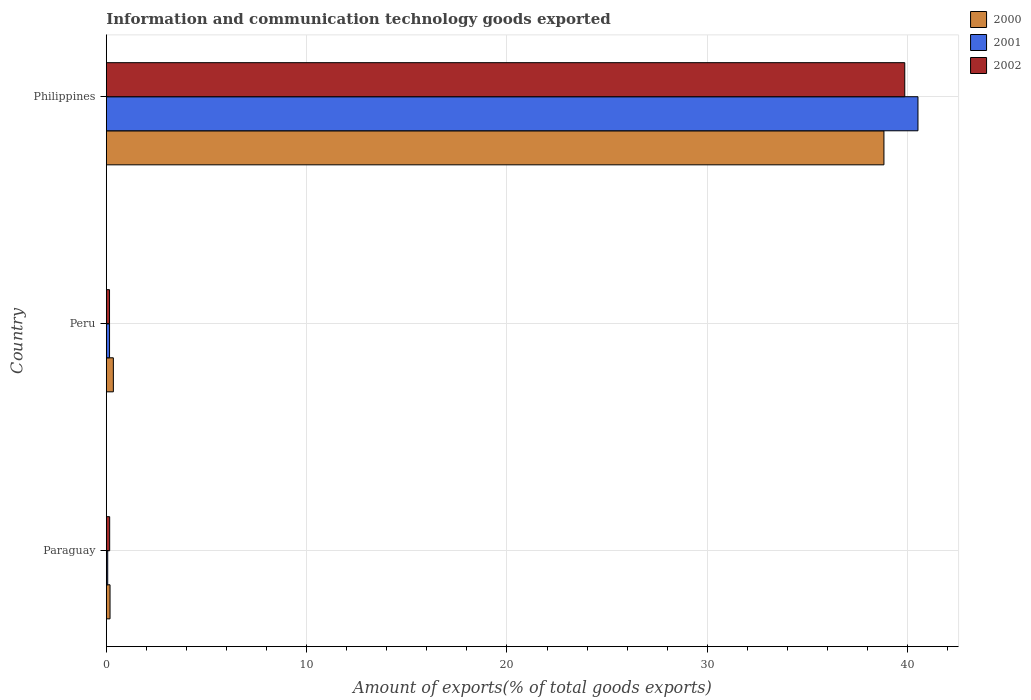How many different coloured bars are there?
Your answer should be very brief. 3. How many groups of bars are there?
Give a very brief answer. 3. Are the number of bars per tick equal to the number of legend labels?
Provide a succinct answer. Yes. How many bars are there on the 3rd tick from the bottom?
Provide a succinct answer. 3. What is the label of the 1st group of bars from the top?
Offer a terse response. Philippines. In how many cases, is the number of bars for a given country not equal to the number of legend labels?
Your response must be concise. 0. What is the amount of goods exported in 2000 in Philippines?
Ensure brevity in your answer.  38.82. Across all countries, what is the maximum amount of goods exported in 2000?
Provide a succinct answer. 38.82. Across all countries, what is the minimum amount of goods exported in 2002?
Your response must be concise. 0.16. In which country was the amount of goods exported in 2001 maximum?
Ensure brevity in your answer.  Philippines. In which country was the amount of goods exported in 2002 minimum?
Your answer should be very brief. Peru. What is the total amount of goods exported in 2002 in the graph?
Provide a succinct answer. 40.19. What is the difference between the amount of goods exported in 2000 in Peru and that in Philippines?
Offer a terse response. -38.47. What is the difference between the amount of goods exported in 2000 in Philippines and the amount of goods exported in 2001 in Paraguay?
Keep it short and to the point. 38.75. What is the average amount of goods exported in 2000 per country?
Your response must be concise. 13.12. What is the difference between the amount of goods exported in 2000 and amount of goods exported in 2002 in Philippines?
Offer a terse response. -1.04. In how many countries, is the amount of goods exported in 2000 greater than 34 %?
Give a very brief answer. 1. What is the ratio of the amount of goods exported in 2000 in Peru to that in Philippines?
Your response must be concise. 0.01. Is the amount of goods exported in 2000 in Paraguay less than that in Philippines?
Make the answer very short. Yes. Is the difference between the amount of goods exported in 2000 in Paraguay and Peru greater than the difference between the amount of goods exported in 2002 in Paraguay and Peru?
Your response must be concise. No. What is the difference between the highest and the second highest amount of goods exported in 2001?
Your answer should be very brief. 40.36. What is the difference between the highest and the lowest amount of goods exported in 2001?
Provide a succinct answer. 40.45. What does the 1st bar from the top in Paraguay represents?
Your answer should be very brief. 2002. How many bars are there?
Offer a very short reply. 9. Are all the bars in the graph horizontal?
Give a very brief answer. Yes. Are the values on the major ticks of X-axis written in scientific E-notation?
Keep it short and to the point. No. Where does the legend appear in the graph?
Keep it short and to the point. Top right. What is the title of the graph?
Your answer should be compact. Information and communication technology goods exported. What is the label or title of the X-axis?
Your answer should be compact. Amount of exports(% of total goods exports). What is the label or title of the Y-axis?
Offer a very short reply. Country. What is the Amount of exports(% of total goods exports) of 2000 in Paraguay?
Keep it short and to the point. 0.18. What is the Amount of exports(% of total goods exports) of 2001 in Paraguay?
Make the answer very short. 0.07. What is the Amount of exports(% of total goods exports) of 2002 in Paraguay?
Your answer should be very brief. 0.17. What is the Amount of exports(% of total goods exports) in 2000 in Peru?
Ensure brevity in your answer.  0.35. What is the Amount of exports(% of total goods exports) in 2001 in Peru?
Your answer should be compact. 0.16. What is the Amount of exports(% of total goods exports) in 2002 in Peru?
Give a very brief answer. 0.16. What is the Amount of exports(% of total goods exports) in 2000 in Philippines?
Provide a short and direct response. 38.82. What is the Amount of exports(% of total goods exports) in 2001 in Philippines?
Ensure brevity in your answer.  40.52. What is the Amount of exports(% of total goods exports) in 2002 in Philippines?
Make the answer very short. 39.86. Across all countries, what is the maximum Amount of exports(% of total goods exports) in 2000?
Ensure brevity in your answer.  38.82. Across all countries, what is the maximum Amount of exports(% of total goods exports) of 2001?
Ensure brevity in your answer.  40.52. Across all countries, what is the maximum Amount of exports(% of total goods exports) in 2002?
Offer a very short reply. 39.86. Across all countries, what is the minimum Amount of exports(% of total goods exports) in 2000?
Your answer should be compact. 0.18. Across all countries, what is the minimum Amount of exports(% of total goods exports) of 2001?
Keep it short and to the point. 0.07. Across all countries, what is the minimum Amount of exports(% of total goods exports) in 2002?
Your answer should be compact. 0.16. What is the total Amount of exports(% of total goods exports) of 2000 in the graph?
Give a very brief answer. 39.36. What is the total Amount of exports(% of total goods exports) in 2001 in the graph?
Provide a succinct answer. 40.75. What is the total Amount of exports(% of total goods exports) of 2002 in the graph?
Give a very brief answer. 40.19. What is the difference between the Amount of exports(% of total goods exports) in 2000 in Paraguay and that in Peru?
Keep it short and to the point. -0.17. What is the difference between the Amount of exports(% of total goods exports) of 2001 in Paraguay and that in Peru?
Offer a terse response. -0.09. What is the difference between the Amount of exports(% of total goods exports) in 2002 in Paraguay and that in Peru?
Provide a succinct answer. 0.01. What is the difference between the Amount of exports(% of total goods exports) of 2000 in Paraguay and that in Philippines?
Your answer should be compact. -38.64. What is the difference between the Amount of exports(% of total goods exports) of 2001 in Paraguay and that in Philippines?
Offer a terse response. -40.45. What is the difference between the Amount of exports(% of total goods exports) in 2002 in Paraguay and that in Philippines?
Your answer should be very brief. -39.69. What is the difference between the Amount of exports(% of total goods exports) in 2000 in Peru and that in Philippines?
Keep it short and to the point. -38.47. What is the difference between the Amount of exports(% of total goods exports) of 2001 in Peru and that in Philippines?
Give a very brief answer. -40.36. What is the difference between the Amount of exports(% of total goods exports) of 2002 in Peru and that in Philippines?
Your answer should be very brief. -39.7. What is the difference between the Amount of exports(% of total goods exports) of 2000 in Paraguay and the Amount of exports(% of total goods exports) of 2001 in Peru?
Offer a terse response. 0.02. What is the difference between the Amount of exports(% of total goods exports) of 2000 in Paraguay and the Amount of exports(% of total goods exports) of 2002 in Peru?
Make the answer very short. 0.02. What is the difference between the Amount of exports(% of total goods exports) of 2001 in Paraguay and the Amount of exports(% of total goods exports) of 2002 in Peru?
Provide a short and direct response. -0.09. What is the difference between the Amount of exports(% of total goods exports) in 2000 in Paraguay and the Amount of exports(% of total goods exports) in 2001 in Philippines?
Your answer should be compact. -40.34. What is the difference between the Amount of exports(% of total goods exports) of 2000 in Paraguay and the Amount of exports(% of total goods exports) of 2002 in Philippines?
Keep it short and to the point. -39.68. What is the difference between the Amount of exports(% of total goods exports) of 2001 in Paraguay and the Amount of exports(% of total goods exports) of 2002 in Philippines?
Ensure brevity in your answer.  -39.79. What is the difference between the Amount of exports(% of total goods exports) in 2000 in Peru and the Amount of exports(% of total goods exports) in 2001 in Philippines?
Make the answer very short. -40.17. What is the difference between the Amount of exports(% of total goods exports) in 2000 in Peru and the Amount of exports(% of total goods exports) in 2002 in Philippines?
Make the answer very short. -39.51. What is the difference between the Amount of exports(% of total goods exports) of 2001 in Peru and the Amount of exports(% of total goods exports) of 2002 in Philippines?
Offer a terse response. -39.7. What is the average Amount of exports(% of total goods exports) in 2000 per country?
Offer a terse response. 13.12. What is the average Amount of exports(% of total goods exports) of 2001 per country?
Offer a terse response. 13.58. What is the average Amount of exports(% of total goods exports) in 2002 per country?
Keep it short and to the point. 13.4. What is the difference between the Amount of exports(% of total goods exports) of 2000 and Amount of exports(% of total goods exports) of 2001 in Paraguay?
Your answer should be compact. 0.12. What is the difference between the Amount of exports(% of total goods exports) in 2000 and Amount of exports(% of total goods exports) in 2002 in Paraguay?
Offer a terse response. 0.02. What is the difference between the Amount of exports(% of total goods exports) of 2001 and Amount of exports(% of total goods exports) of 2002 in Paraguay?
Provide a short and direct response. -0.1. What is the difference between the Amount of exports(% of total goods exports) in 2000 and Amount of exports(% of total goods exports) in 2001 in Peru?
Provide a short and direct response. 0.19. What is the difference between the Amount of exports(% of total goods exports) in 2000 and Amount of exports(% of total goods exports) in 2002 in Peru?
Your response must be concise. 0.19. What is the difference between the Amount of exports(% of total goods exports) of 2000 and Amount of exports(% of total goods exports) of 2001 in Philippines?
Your answer should be very brief. -1.7. What is the difference between the Amount of exports(% of total goods exports) in 2000 and Amount of exports(% of total goods exports) in 2002 in Philippines?
Make the answer very short. -1.04. What is the difference between the Amount of exports(% of total goods exports) in 2001 and Amount of exports(% of total goods exports) in 2002 in Philippines?
Provide a succinct answer. 0.66. What is the ratio of the Amount of exports(% of total goods exports) of 2000 in Paraguay to that in Peru?
Give a very brief answer. 0.53. What is the ratio of the Amount of exports(% of total goods exports) in 2001 in Paraguay to that in Peru?
Keep it short and to the point. 0.43. What is the ratio of the Amount of exports(% of total goods exports) of 2002 in Paraguay to that in Peru?
Offer a very short reply. 1.04. What is the ratio of the Amount of exports(% of total goods exports) in 2000 in Paraguay to that in Philippines?
Your answer should be compact. 0. What is the ratio of the Amount of exports(% of total goods exports) of 2001 in Paraguay to that in Philippines?
Your response must be concise. 0. What is the ratio of the Amount of exports(% of total goods exports) of 2002 in Paraguay to that in Philippines?
Make the answer very short. 0. What is the ratio of the Amount of exports(% of total goods exports) in 2000 in Peru to that in Philippines?
Your answer should be compact. 0.01. What is the ratio of the Amount of exports(% of total goods exports) of 2001 in Peru to that in Philippines?
Make the answer very short. 0. What is the ratio of the Amount of exports(% of total goods exports) of 2002 in Peru to that in Philippines?
Keep it short and to the point. 0. What is the difference between the highest and the second highest Amount of exports(% of total goods exports) in 2000?
Make the answer very short. 38.47. What is the difference between the highest and the second highest Amount of exports(% of total goods exports) in 2001?
Your answer should be compact. 40.36. What is the difference between the highest and the second highest Amount of exports(% of total goods exports) of 2002?
Keep it short and to the point. 39.69. What is the difference between the highest and the lowest Amount of exports(% of total goods exports) of 2000?
Keep it short and to the point. 38.64. What is the difference between the highest and the lowest Amount of exports(% of total goods exports) in 2001?
Your answer should be very brief. 40.45. What is the difference between the highest and the lowest Amount of exports(% of total goods exports) of 2002?
Offer a very short reply. 39.7. 